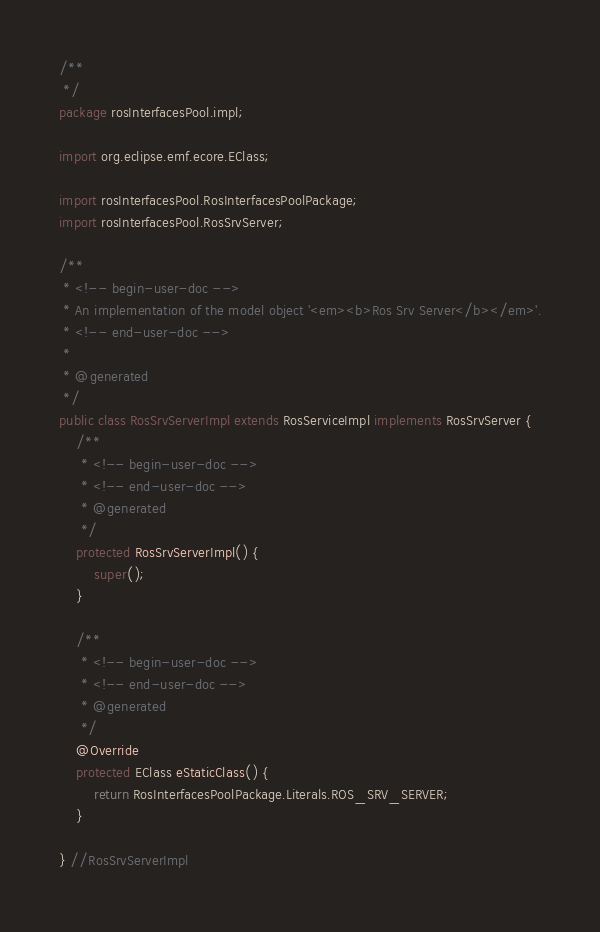Convert code to text. <code><loc_0><loc_0><loc_500><loc_500><_Java_>/**
 */
package rosInterfacesPool.impl;

import org.eclipse.emf.ecore.EClass;

import rosInterfacesPool.RosInterfacesPoolPackage;
import rosInterfacesPool.RosSrvServer;

/**
 * <!-- begin-user-doc -->
 * An implementation of the model object '<em><b>Ros Srv Server</b></em>'.
 * <!-- end-user-doc -->
 *
 * @generated
 */
public class RosSrvServerImpl extends RosServiceImpl implements RosSrvServer {
	/**
	 * <!-- begin-user-doc -->
	 * <!-- end-user-doc -->
	 * @generated
	 */
	protected RosSrvServerImpl() {
		super();
	}

	/**
	 * <!-- begin-user-doc -->
	 * <!-- end-user-doc -->
	 * @generated
	 */
	@Override
	protected EClass eStaticClass() {
		return RosInterfacesPoolPackage.Literals.ROS_SRV_SERVER;
	}

} //RosSrvServerImpl
</code> 